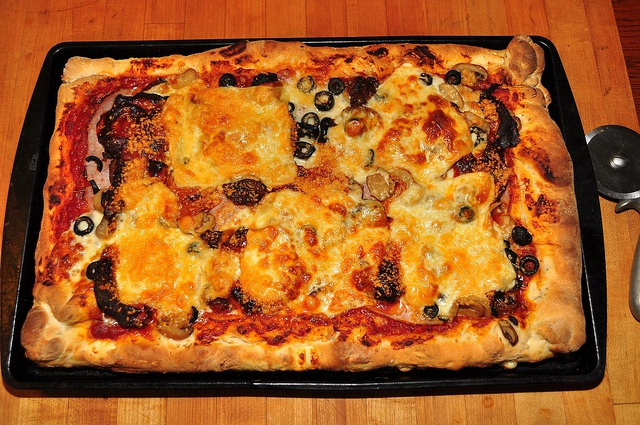Describe the objects in this image and their specific colors. I can see dining table in red, black, and orange tones and pizza in brown, orange, and red tones in this image. 